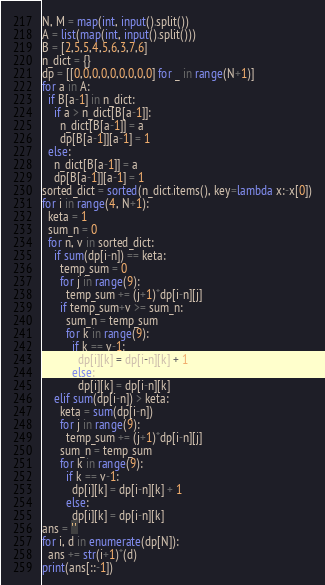Convert code to text. <code><loc_0><loc_0><loc_500><loc_500><_Python_>N, M = map(int, input().split())
A = list(map(int, input().split()))
B = [2,5,5,4,5,6,3,7,6]
n_dict = {}
dp = [[0,0,0,0,0,0,0,0,0] for _ in range(N+1)]
for a in A:
  if B[a-1] in n_dict:
    if a > n_dict[B[a-1]]:
      n_dict[B[a-1]] = a
      dp[B[a-1]][a-1] = 1
  else:
    n_dict[B[a-1]] = a
    dp[B[a-1]][a-1] = 1
sorted_dict = sorted(n_dict.items(), key=lambda x:-x[0])
for i in range(4, N+1):
  keta = 1
  sum_n = 0
  for n, v in sorted_dict:
    if sum(dp[i-n]) == keta:
      temp_sum = 0
      for j in range(9):
        temp_sum += (j+1)*dp[i-n][j]
      if temp_sum+v >= sum_n:
        sum_n = temp_sum
        for k in range(9):
          if k == v-1:
            dp[i][k] = dp[i-n][k] + 1
          else:
            dp[i][k] = dp[i-n][k]
    elif sum(dp[i-n]) > keta:
      keta = sum(dp[i-n])
      for j in range(9):
        temp_sum += (j+1)*dp[i-n][j]
      sum_n = temp_sum
      for k in range(9):
        if k == v-1:
          dp[i][k] = dp[i-n][k] + 1
        else:
          dp[i][k] = dp[i-n][k]
ans = ''
for i, d in enumerate(dp[N]):
  ans += str(i+1)*(d)
print(ans[::-1])
</code> 